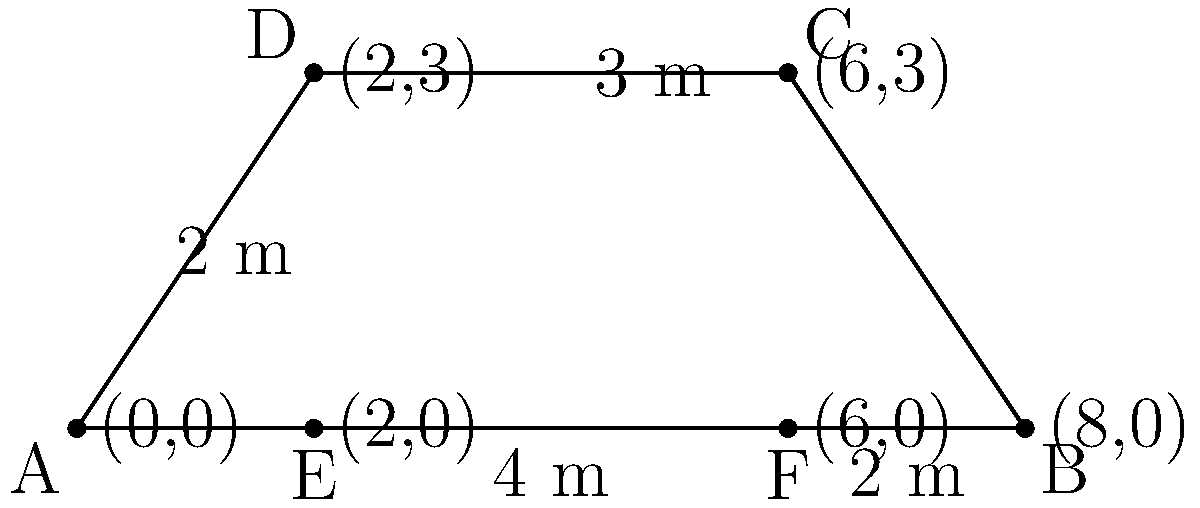For The Verve Pipe's upcoming concert, you're analyzing their stage setup. The main platform is a trapezoid, as shown in the diagram. If the stage is 0.5 meters high, what is the total surface area of the platform, including the top and all four sides? To find the total surface area, we need to calculate the areas of the top and all four sides:

1. Top area (trapezoid):
   Area = $\frac{1}{2}(a+b)h$, where $a$ and $b$ are parallel sides and $h$ is the height
   $A_{top} = \frac{1}{2}(8+2) \cdot 3 = 15$ m²

2. Front and back sides (rectangles):
   $A_{front} = A_{back} = 8 \cdot 0.5 = 4$ m² each
   Total for front and back: $2 \cdot 4 = 8$ m²

3. Left side (rectangle):
   $A_{left} = 3 \cdot 0.5 = 1.5$ m²

4. Right side (rectangle):
   $A_{right} = 3 \cdot 0.5 = 1.5$ m²

Total surface area:
$A_{total} = A_{top} + A_{front} + A_{back} + A_{left} + A_{right}$
$A_{total} = 15 + 8 + 1.5 + 1.5 = 26$ m²
Answer: 26 m² 